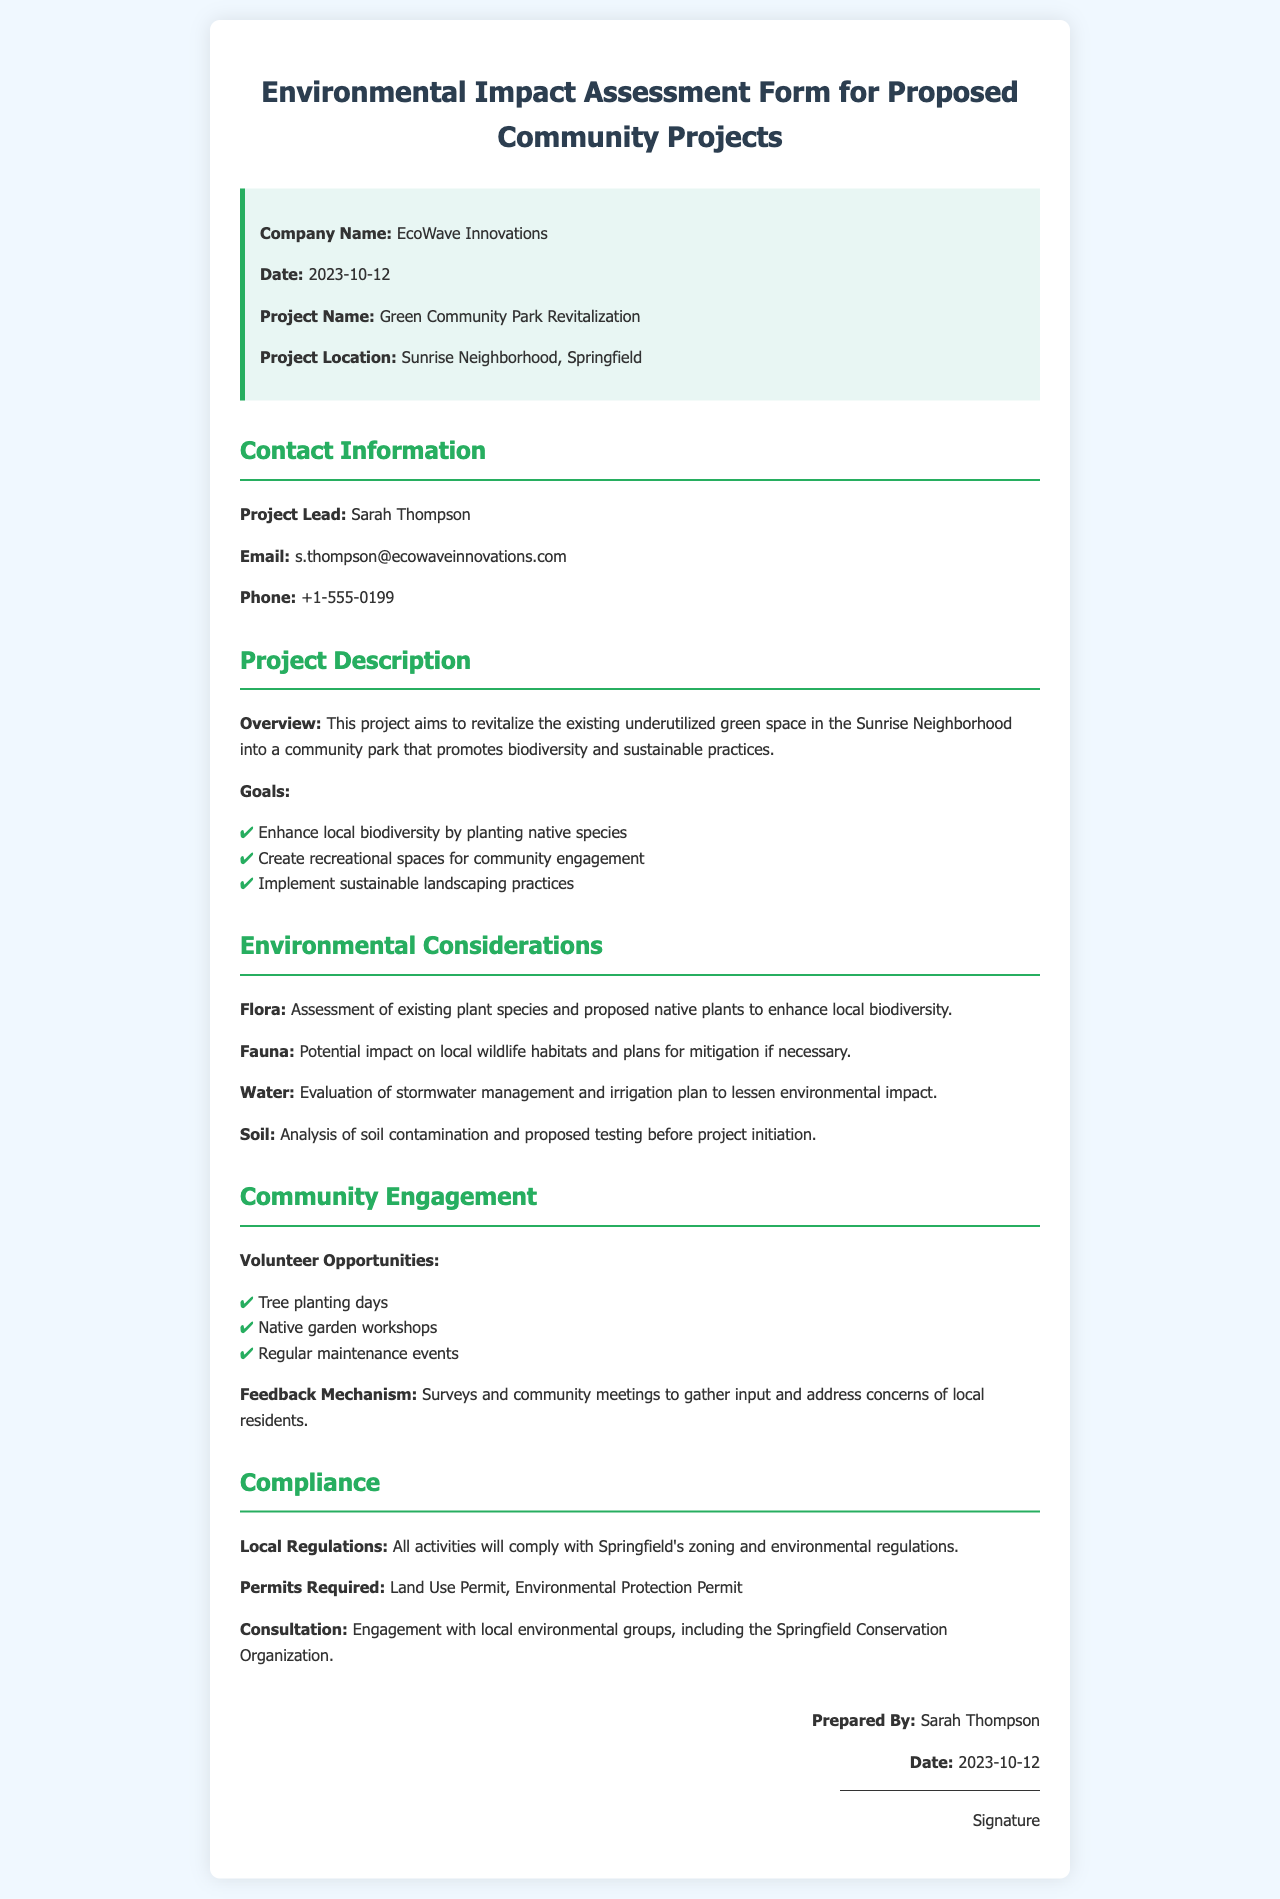What is the company name? The company name is stated at the beginning of the document in the company information block.
Answer: EcoWave Innovations What is the project name? The project name is detailed under the project information section.
Answer: Green Community Park Revitalization Who is the project lead? The project lead's name is provided in the contact information section of the document.
Answer: Sarah Thompson What is the project location? The project location is specified in the project information section of the document.
Answer: Sunrise Neighborhood, Springfield What are the goals of the project? The goals are listed in the project description section and can be summarized as enhancements for biodiversity, recreation, and sustainable practices.
Answer: Enhance local biodiversity, Create recreational spaces, Implement sustainable landscaping practices What kind of community engagement opportunities are available? The document lists specific volunteer activities that will involve community members in the project.
Answer: Tree planting days, Native garden workshops, Regular maintenance events What permits are required for the project? Required permits are listed under the compliance section; they are necessary for legal approval of the project.
Answer: Land Use Permit, Environmental Protection Permit What is the date when the form was prepared? The preparation date can be found at the bottom of the document in the signature section.
Answer: 2023-10-12 What measures are proposed for water management? The document specifies the evaluation of stormwater management and irrigation plans as part of environmental considerations.
Answer: Evaluation of stormwater management and irrigation plan How will compliance with local regulations be ensured? Compliance details are provided in the compliance section, which outlines adherence to regulations and consultation with local groups.
Answer: All activities will comply with Springfield's zoning and environmental regulations 